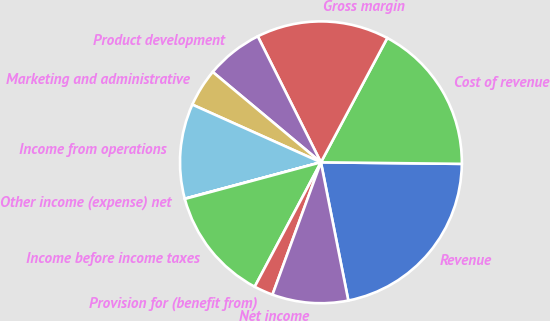Convert chart. <chart><loc_0><loc_0><loc_500><loc_500><pie_chart><fcel>Revenue<fcel>Cost of revenue<fcel>Gross margin<fcel>Product development<fcel>Marketing and administrative<fcel>Income from operations<fcel>Other income (expense) net<fcel>Income before income taxes<fcel>Provision for (benefit from)<fcel>Net income<nl><fcel>21.71%<fcel>17.37%<fcel>15.2%<fcel>6.53%<fcel>4.36%<fcel>10.87%<fcel>0.03%<fcel>13.03%<fcel>2.2%<fcel>8.7%<nl></chart> 